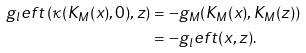Convert formula to latex. <formula><loc_0><loc_0><loc_500><loc_500>g _ { l } e f t \left ( \kappa ( K _ { M } ( x ) , 0 ) , z \right ) & = - g _ { M } ( K _ { M } ( x ) , K _ { M } ( z ) ) \\ & = - g _ { l } e f t ( x , z ) .</formula> 